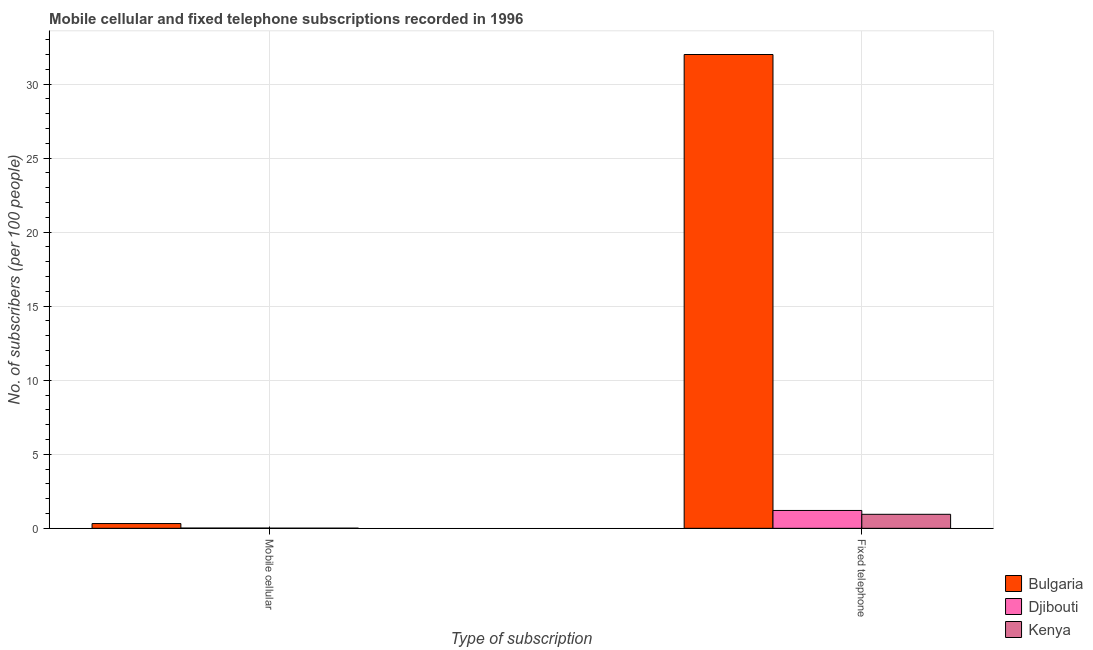How many different coloured bars are there?
Your answer should be very brief. 3. How many groups of bars are there?
Make the answer very short. 2. Are the number of bars per tick equal to the number of legend labels?
Offer a very short reply. Yes. How many bars are there on the 2nd tick from the left?
Keep it short and to the point. 3. How many bars are there on the 2nd tick from the right?
Provide a succinct answer. 3. What is the label of the 2nd group of bars from the left?
Your answer should be very brief. Fixed telephone. What is the number of mobile cellular subscribers in Bulgaria?
Offer a very short reply. 0.32. Across all countries, what is the maximum number of fixed telephone subscribers?
Make the answer very short. 32. Across all countries, what is the minimum number of fixed telephone subscribers?
Offer a very short reply. 0.95. In which country was the number of fixed telephone subscribers minimum?
Provide a short and direct response. Kenya. What is the total number of mobile cellular subscribers in the graph?
Provide a succinct answer. 0.35. What is the difference between the number of mobile cellular subscribers in Djibouti and that in Kenya?
Your answer should be compact. 0.01. What is the difference between the number of mobile cellular subscribers in Kenya and the number of fixed telephone subscribers in Djibouti?
Offer a very short reply. -1.2. What is the average number of mobile cellular subscribers per country?
Keep it short and to the point. 0.12. What is the difference between the number of mobile cellular subscribers and number of fixed telephone subscribers in Bulgaria?
Your answer should be very brief. -31.67. What is the ratio of the number of fixed telephone subscribers in Djibouti to that in Bulgaria?
Your response must be concise. 0.04. What does the 3rd bar from the left in Fixed telephone represents?
Provide a short and direct response. Kenya. What does the 3rd bar from the right in Mobile cellular represents?
Make the answer very short. Bulgaria. Are the values on the major ticks of Y-axis written in scientific E-notation?
Provide a succinct answer. No. Does the graph contain grids?
Your answer should be compact. Yes. Where does the legend appear in the graph?
Provide a succinct answer. Bottom right. What is the title of the graph?
Keep it short and to the point. Mobile cellular and fixed telephone subscriptions recorded in 1996. Does "Cabo Verde" appear as one of the legend labels in the graph?
Provide a succinct answer. No. What is the label or title of the X-axis?
Provide a succinct answer. Type of subscription. What is the label or title of the Y-axis?
Offer a very short reply. No. of subscribers (per 100 people). What is the No. of subscribers (per 100 people) in Bulgaria in Mobile cellular?
Offer a terse response. 0.32. What is the No. of subscribers (per 100 people) in Djibouti in Mobile cellular?
Your response must be concise. 0.02. What is the No. of subscribers (per 100 people) of Kenya in Mobile cellular?
Your response must be concise. 0.01. What is the No. of subscribers (per 100 people) of Bulgaria in Fixed telephone?
Give a very brief answer. 32. What is the No. of subscribers (per 100 people) of Djibouti in Fixed telephone?
Keep it short and to the point. 1.21. What is the No. of subscribers (per 100 people) of Kenya in Fixed telephone?
Offer a terse response. 0.95. Across all Type of subscription, what is the maximum No. of subscribers (per 100 people) of Bulgaria?
Your answer should be very brief. 32. Across all Type of subscription, what is the maximum No. of subscribers (per 100 people) of Djibouti?
Keep it short and to the point. 1.21. Across all Type of subscription, what is the maximum No. of subscribers (per 100 people) of Kenya?
Your answer should be very brief. 0.95. Across all Type of subscription, what is the minimum No. of subscribers (per 100 people) in Bulgaria?
Your answer should be compact. 0.32. Across all Type of subscription, what is the minimum No. of subscribers (per 100 people) of Djibouti?
Offer a terse response. 0.02. Across all Type of subscription, what is the minimum No. of subscribers (per 100 people) of Kenya?
Keep it short and to the point. 0.01. What is the total No. of subscribers (per 100 people) of Bulgaria in the graph?
Provide a short and direct response. 32.32. What is the total No. of subscribers (per 100 people) in Djibouti in the graph?
Give a very brief answer. 1.22. What is the total No. of subscribers (per 100 people) of Kenya in the graph?
Your answer should be compact. 0.96. What is the difference between the No. of subscribers (per 100 people) in Bulgaria in Mobile cellular and that in Fixed telephone?
Give a very brief answer. -31.67. What is the difference between the No. of subscribers (per 100 people) in Djibouti in Mobile cellular and that in Fixed telephone?
Your response must be concise. -1.19. What is the difference between the No. of subscribers (per 100 people) of Kenya in Mobile cellular and that in Fixed telephone?
Provide a short and direct response. -0.94. What is the difference between the No. of subscribers (per 100 people) in Bulgaria in Mobile cellular and the No. of subscribers (per 100 people) in Djibouti in Fixed telephone?
Give a very brief answer. -0.88. What is the difference between the No. of subscribers (per 100 people) of Bulgaria in Mobile cellular and the No. of subscribers (per 100 people) of Kenya in Fixed telephone?
Give a very brief answer. -0.63. What is the difference between the No. of subscribers (per 100 people) in Djibouti in Mobile cellular and the No. of subscribers (per 100 people) in Kenya in Fixed telephone?
Make the answer very short. -0.93. What is the average No. of subscribers (per 100 people) in Bulgaria per Type of subscription?
Your answer should be very brief. 16.16. What is the average No. of subscribers (per 100 people) in Djibouti per Type of subscription?
Offer a terse response. 0.61. What is the average No. of subscribers (per 100 people) of Kenya per Type of subscription?
Offer a very short reply. 0.48. What is the difference between the No. of subscribers (per 100 people) of Bulgaria and No. of subscribers (per 100 people) of Djibouti in Mobile cellular?
Your response must be concise. 0.3. What is the difference between the No. of subscribers (per 100 people) in Bulgaria and No. of subscribers (per 100 people) in Kenya in Mobile cellular?
Ensure brevity in your answer.  0.31. What is the difference between the No. of subscribers (per 100 people) of Djibouti and No. of subscribers (per 100 people) of Kenya in Mobile cellular?
Provide a short and direct response. 0.01. What is the difference between the No. of subscribers (per 100 people) in Bulgaria and No. of subscribers (per 100 people) in Djibouti in Fixed telephone?
Your response must be concise. 30.79. What is the difference between the No. of subscribers (per 100 people) of Bulgaria and No. of subscribers (per 100 people) of Kenya in Fixed telephone?
Provide a succinct answer. 31.05. What is the difference between the No. of subscribers (per 100 people) of Djibouti and No. of subscribers (per 100 people) of Kenya in Fixed telephone?
Ensure brevity in your answer.  0.26. What is the ratio of the No. of subscribers (per 100 people) of Bulgaria in Mobile cellular to that in Fixed telephone?
Make the answer very short. 0.01. What is the ratio of the No. of subscribers (per 100 people) of Djibouti in Mobile cellular to that in Fixed telephone?
Offer a terse response. 0.01. What is the ratio of the No. of subscribers (per 100 people) in Kenya in Mobile cellular to that in Fixed telephone?
Your response must be concise. 0.01. What is the difference between the highest and the second highest No. of subscribers (per 100 people) of Bulgaria?
Give a very brief answer. 31.67. What is the difference between the highest and the second highest No. of subscribers (per 100 people) of Djibouti?
Offer a terse response. 1.19. What is the difference between the highest and the second highest No. of subscribers (per 100 people) of Kenya?
Your response must be concise. 0.94. What is the difference between the highest and the lowest No. of subscribers (per 100 people) in Bulgaria?
Your response must be concise. 31.67. What is the difference between the highest and the lowest No. of subscribers (per 100 people) in Djibouti?
Your answer should be compact. 1.19. What is the difference between the highest and the lowest No. of subscribers (per 100 people) of Kenya?
Make the answer very short. 0.94. 